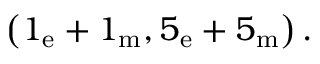Convert formula to latex. <formula><loc_0><loc_0><loc_500><loc_500>\left ( 1 _ { e } + 1 _ { m } , 5 _ { e } + 5 _ { m } \right ) \, .</formula> 